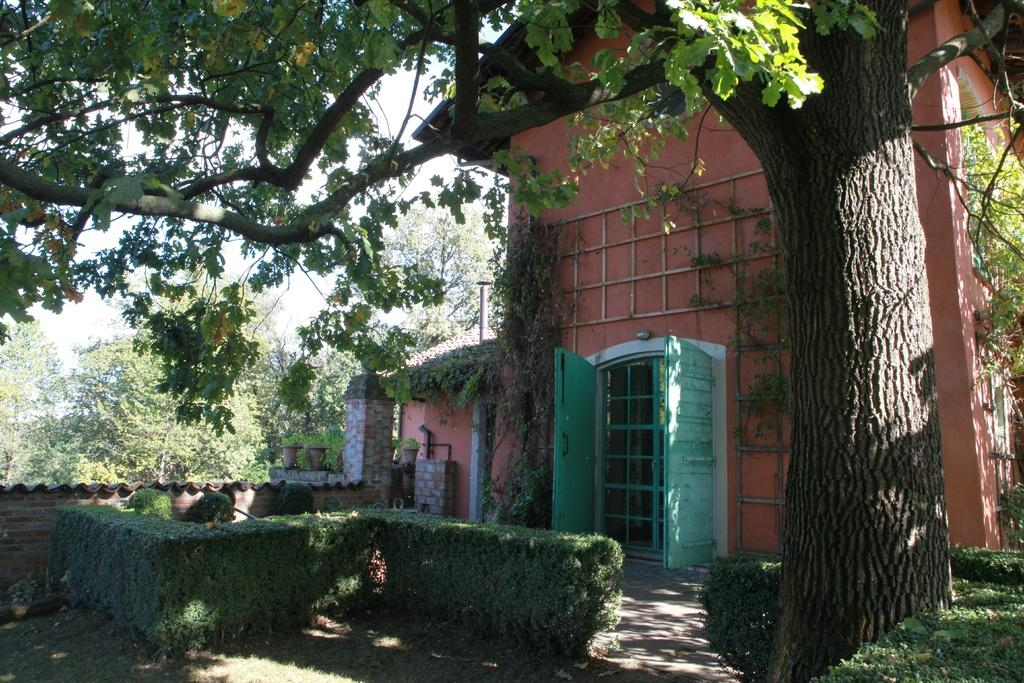What is located at the front of the image? There is a tree in the front of the image. What can be seen in the background of the image? There is a building, green color doors, bushes, and trees in the background of the image. What type of treatment is being administered to the jar in the image? There is no jar present in the image, so no treatment can be administered to it. How many cherries are visible on the tree in the image? There are no cherries mentioned or visible on the tree in the image. 